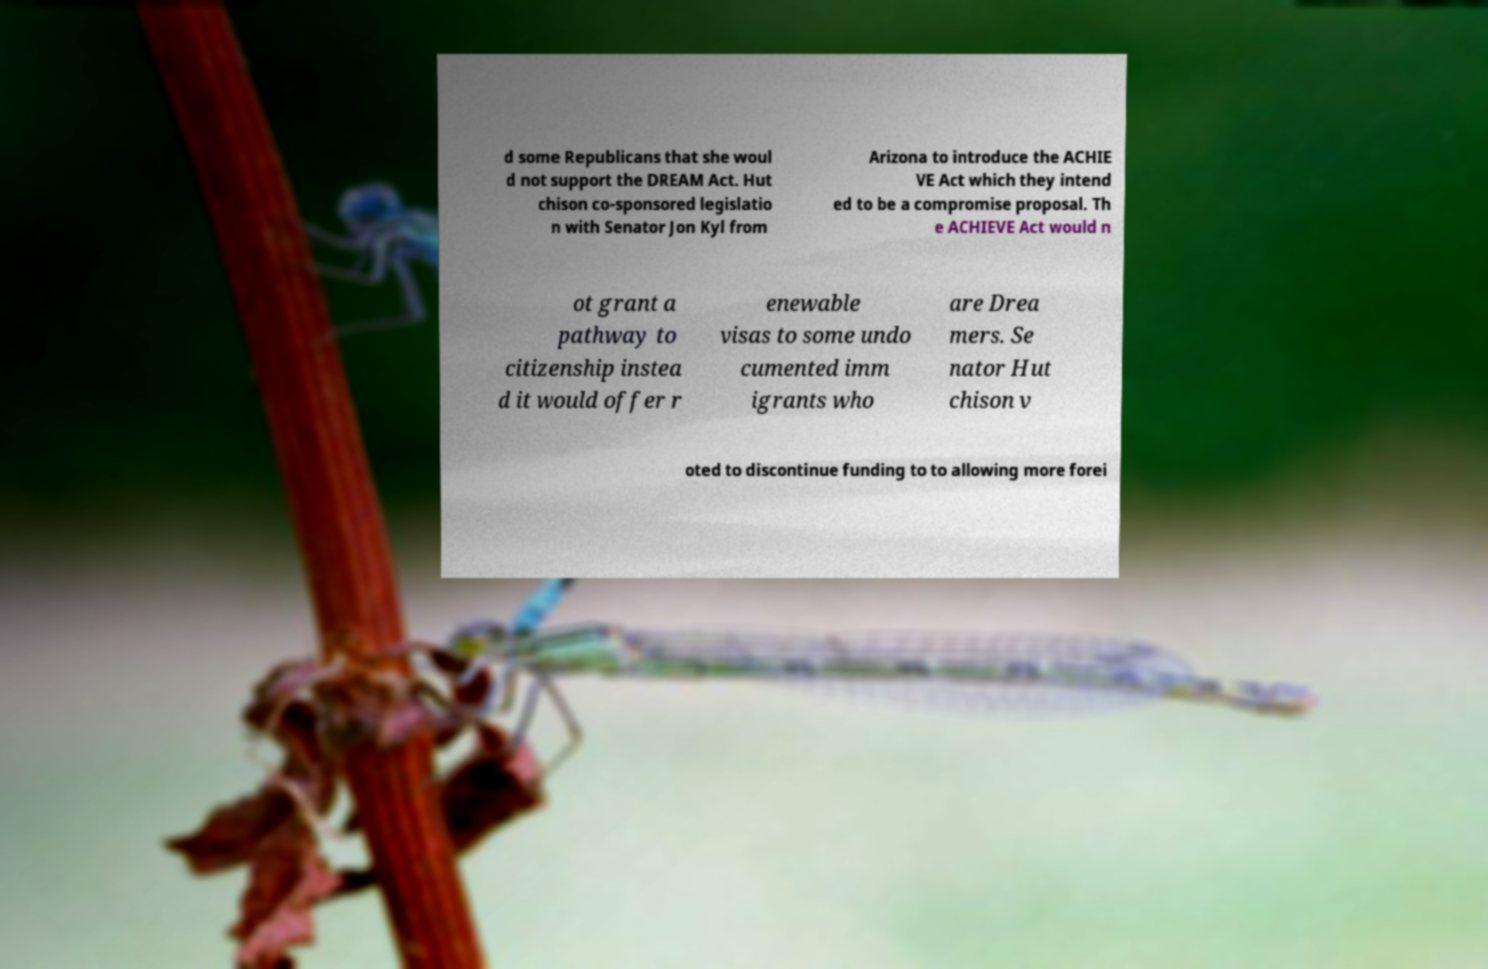Can you accurately transcribe the text from the provided image for me? d some Republicans that she woul d not support the DREAM Act. Hut chison co-sponsored legislatio n with Senator Jon Kyl from Arizona to introduce the ACHIE VE Act which they intend ed to be a compromise proposal. Th e ACHIEVE Act would n ot grant a pathway to citizenship instea d it would offer r enewable visas to some undo cumented imm igrants who are Drea mers. Se nator Hut chison v oted to discontinue funding to to allowing more forei 